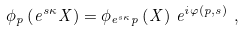<formula> <loc_0><loc_0><loc_500><loc_500>\phi _ { p } \left ( e ^ { s \kappa } X \right ) = \phi _ { e ^ { s \kappa } p } \left ( X \right ) \, e ^ { i \varphi \left ( p , s \right ) } \ ,</formula> 